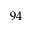<formula> <loc_0><loc_0><loc_500><loc_500>9 4</formula> 